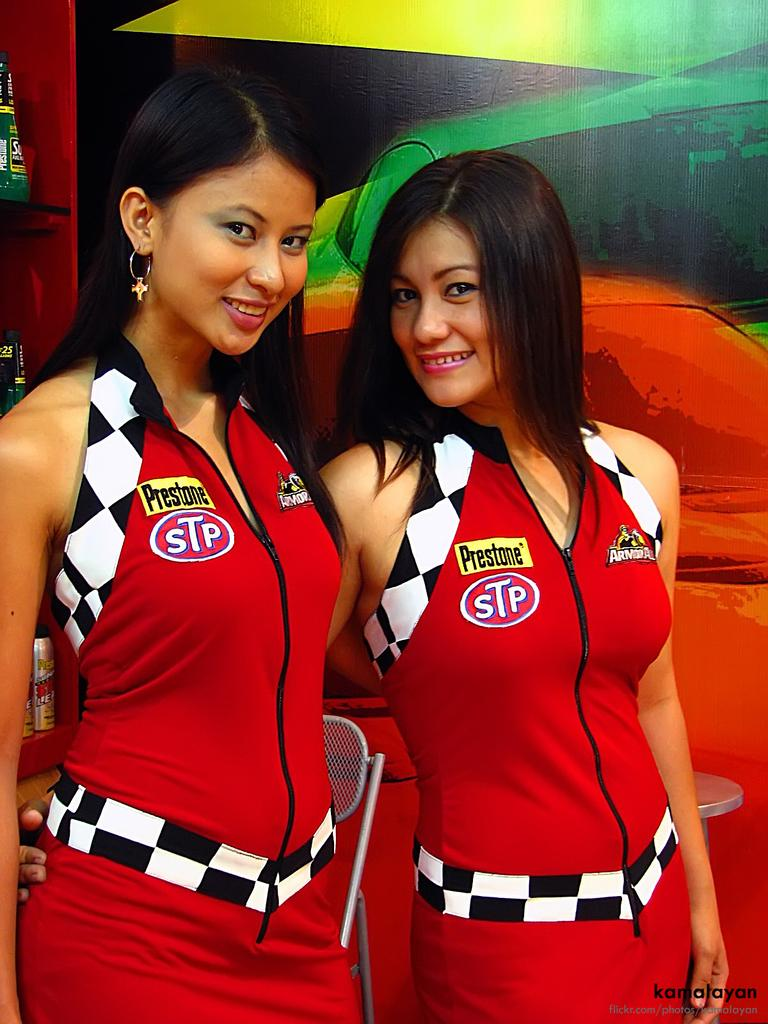<image>
Share a concise interpretation of the image provided. two women wearing red STP dresses smiling in front of a red car 